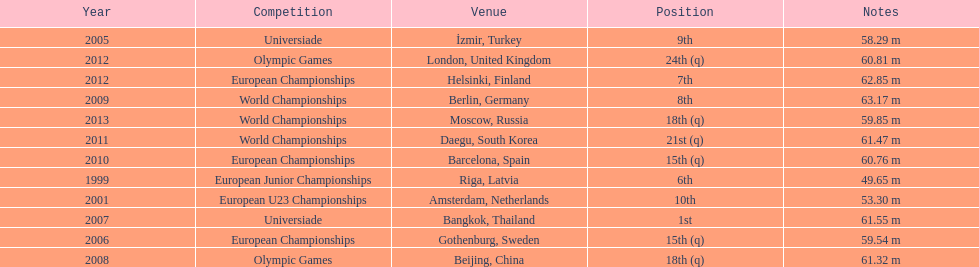What are the total number of times european junior championships is listed as the competition? 1. 